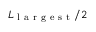<formula> <loc_0><loc_0><loc_500><loc_500>L _ { l a r g e s t } / 2</formula> 